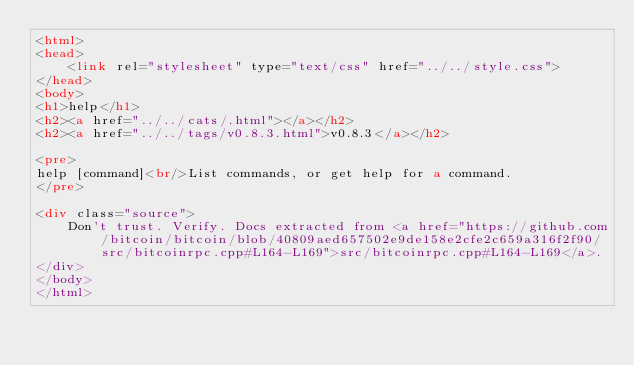Convert code to text. <code><loc_0><loc_0><loc_500><loc_500><_HTML_><html>
<head>
    <link rel="stylesheet" type="text/css" href="../../style.css">
</head>
<body>
<h1>help</h1>
<h2><a href="../../cats/.html"></a></h2>
<h2><a href="../../tags/v0.8.3.html">v0.8.3</a></h2>

<pre>
help [command]<br/>List commands, or get help for a command.
</pre>

<div class="source">
    Don't trust. Verify. Docs extracted from <a href="https://github.com/bitcoin/bitcoin/blob/40809aed657502e9de158e2cfe2c659a316f2f90/src/bitcoinrpc.cpp#L164-L169">src/bitcoinrpc.cpp#L164-L169</a>.
</div>
</body>
</html>
</code> 